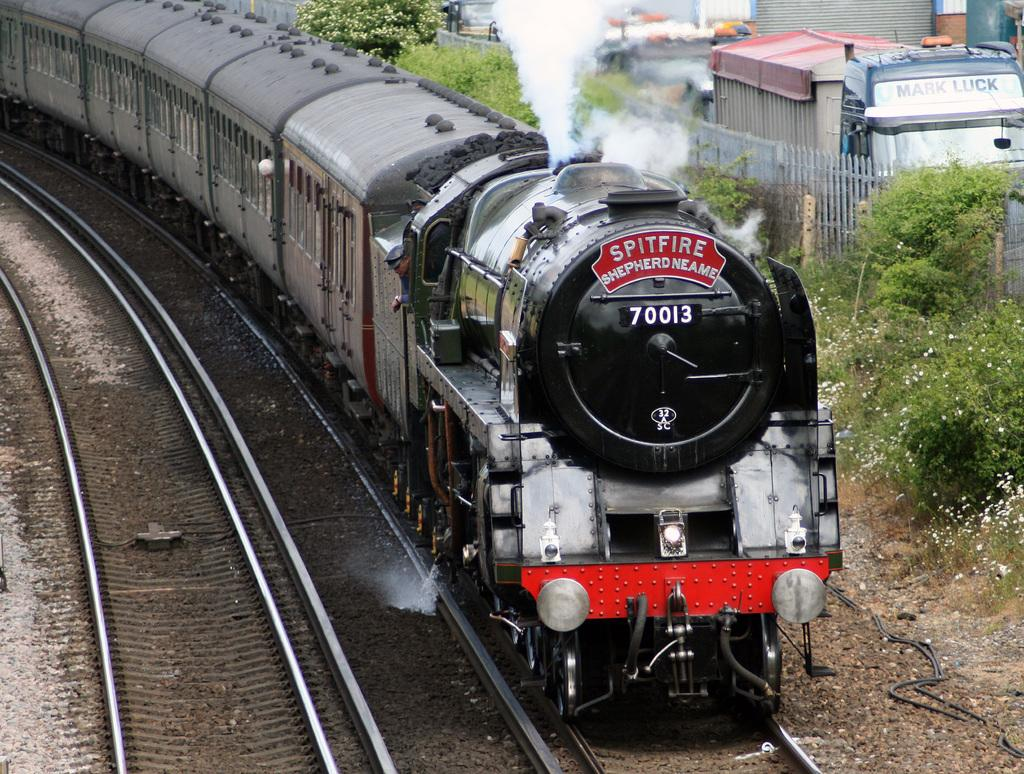<image>
Summarize the visual content of the image. A Spitfire train moving down the train tracks. 